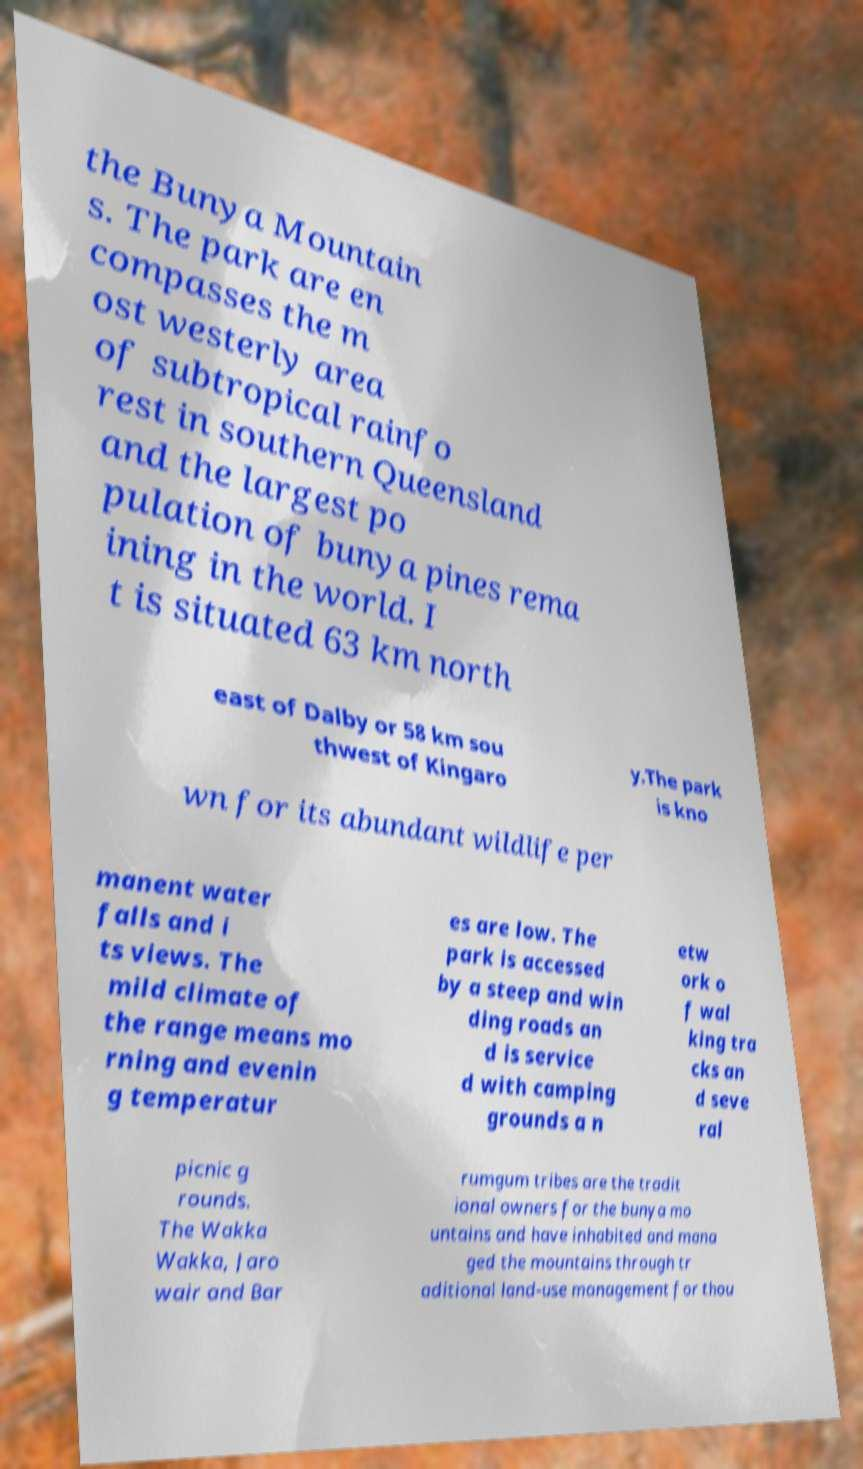For documentation purposes, I need the text within this image transcribed. Could you provide that? the Bunya Mountain s. The park are en compasses the m ost westerly area of subtropical rainfo rest in southern Queensland and the largest po pulation of bunya pines rema ining in the world. I t is situated 63 km north east of Dalby or 58 km sou thwest of Kingaro y.The park is kno wn for its abundant wildlife per manent water falls and i ts views. The mild climate of the range means mo rning and evenin g temperatur es are low. The park is accessed by a steep and win ding roads an d is service d with camping grounds a n etw ork o f wal king tra cks an d seve ral picnic g rounds. The Wakka Wakka, Jaro wair and Bar rumgum tribes are the tradit ional owners for the bunya mo untains and have inhabited and mana ged the mountains through tr aditional land-use management for thou 